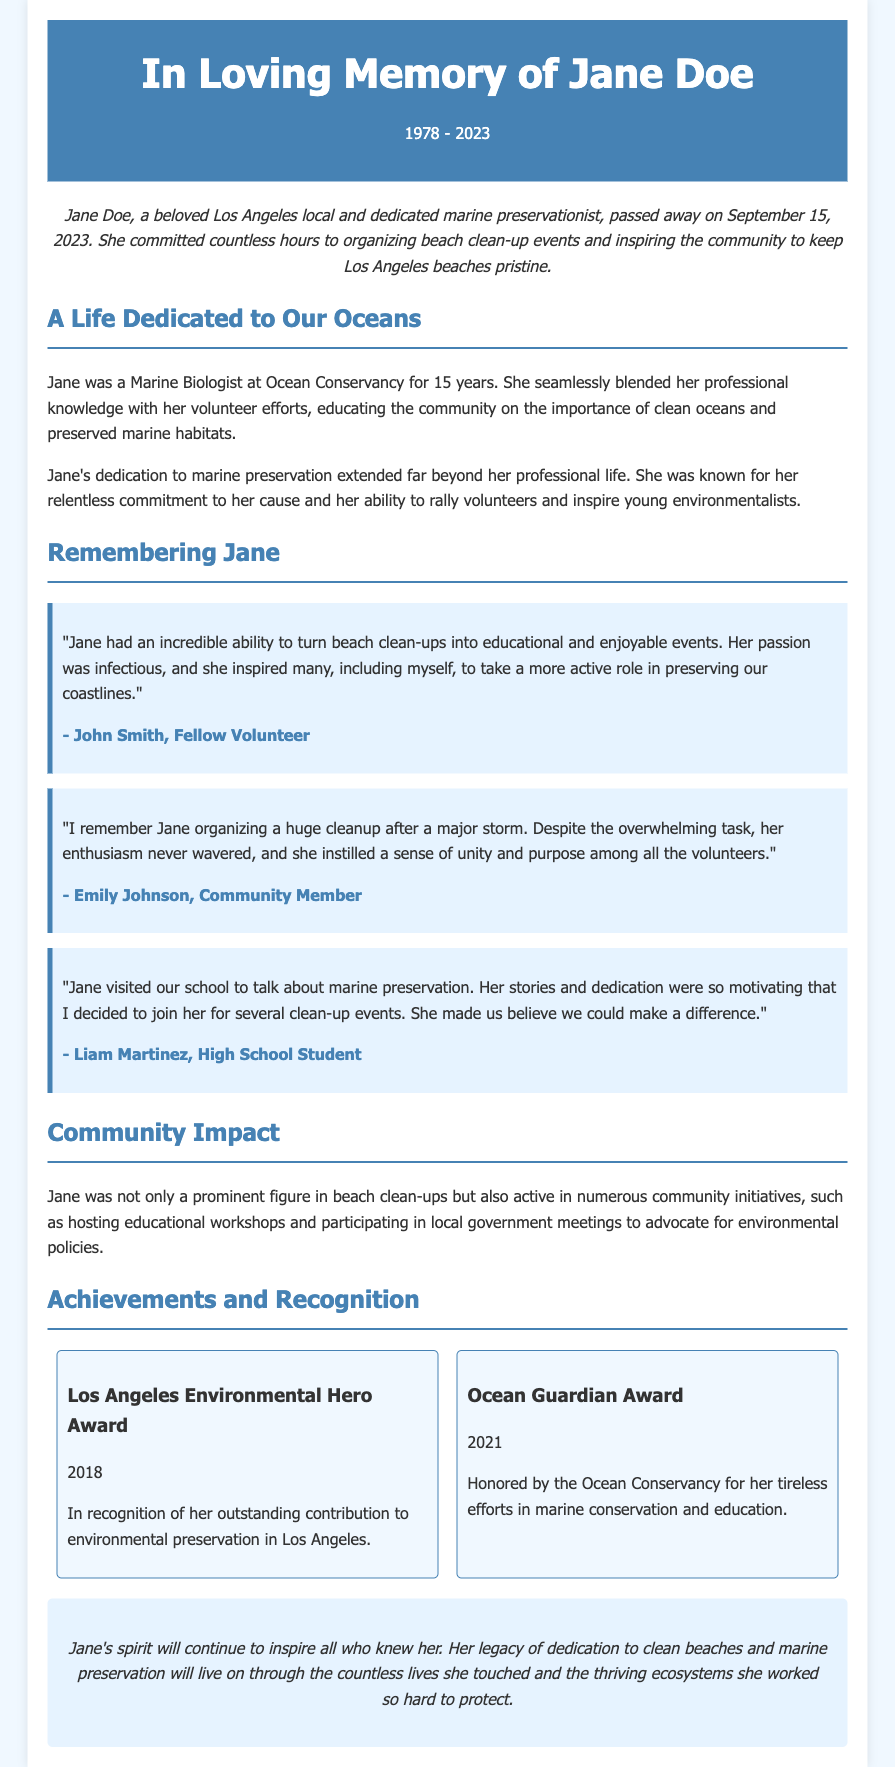What was Jane Doe's profession? Jane was a Marine Biologist at Ocean Conservancy for 15 years, as stated in the document.
Answer: Marine Biologist When did Jane Doe pass away? The document specifies the date of her passing as September 15, 2023.
Answer: September 15, 2023 How many awards did Jane receive mentioned in the document? The document lists two awards that Jane received, which include the Los Angeles Environmental Hero Award and the Ocean Guardian Award.
Answer: 2 What type of events did Jane organize? The document states that she organized beach clean-up events, which is a specific activity she was involved in.
Answer: Beach clean-up events Who described Jane's enthusiasm after a major storm cleanup? Emily Johnson, a community member, is quoted in the document describing Jane's enthusiasm during a cleanup after a storm.
Answer: Emily Johnson What was the purpose of Jane's visit to schools? The document mentions that Jane visited schools to talk about marine preservation, indicating her role in education.
Answer: Marine preservation Which award did Jane receive in 2021? The document indicates that she received the Ocean Guardian Award in 2021 for her conservation efforts.
Answer: Ocean Guardian Award What did Jane inspire her peers to do? The document mentions that Jane inspired many to take a more active role in preserving coastlines, implying her influence on community involvement.
Answer: Preserve coastlines What year did Jane receive the Los Angeles Environmental Hero Award? The document states that Jane received the Los Angeles Environmental Hero Award in 2018, providing the specific year of the award.
Answer: 2018 